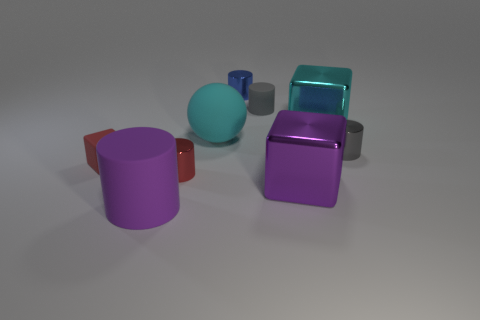Subtract all large metal blocks. How many blocks are left? 1 Add 1 big purple matte objects. How many objects exist? 10 Subtract all red blocks. How many blocks are left? 2 Subtract 2 blocks. How many blocks are left? 1 Subtract all spheres. How many objects are left? 8 Subtract all big brown metal objects. Subtract all tiny gray matte things. How many objects are left? 8 Add 1 tiny rubber cylinders. How many tiny rubber cylinders are left? 2 Add 5 blue metal objects. How many blue metal objects exist? 6 Subtract 0 brown balls. How many objects are left? 9 Subtract all blue balls. Subtract all blue blocks. How many balls are left? 1 